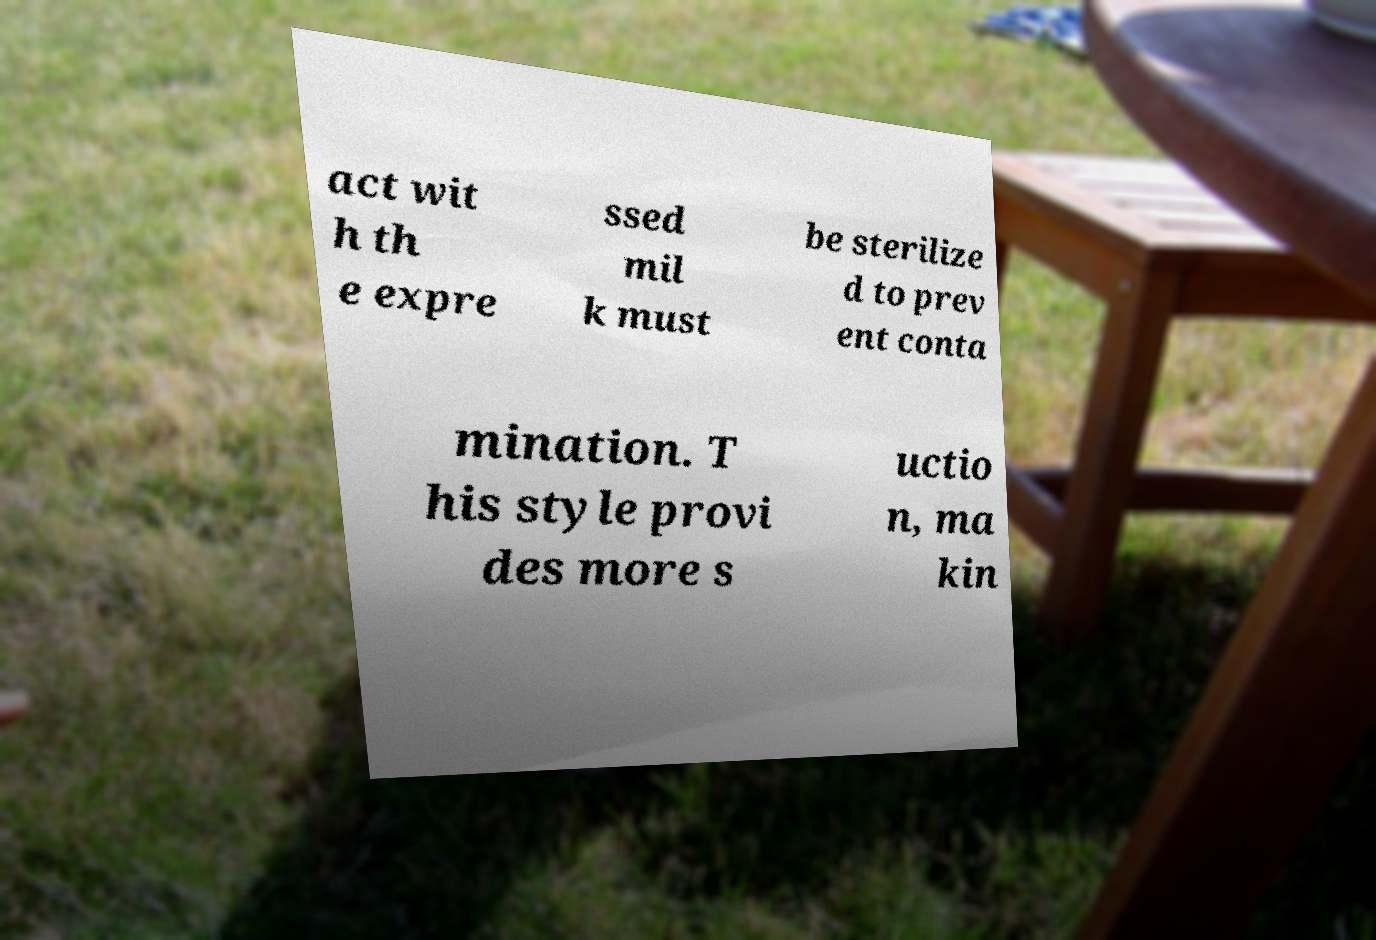For documentation purposes, I need the text within this image transcribed. Could you provide that? act wit h th e expre ssed mil k must be sterilize d to prev ent conta mination. T his style provi des more s uctio n, ma kin 